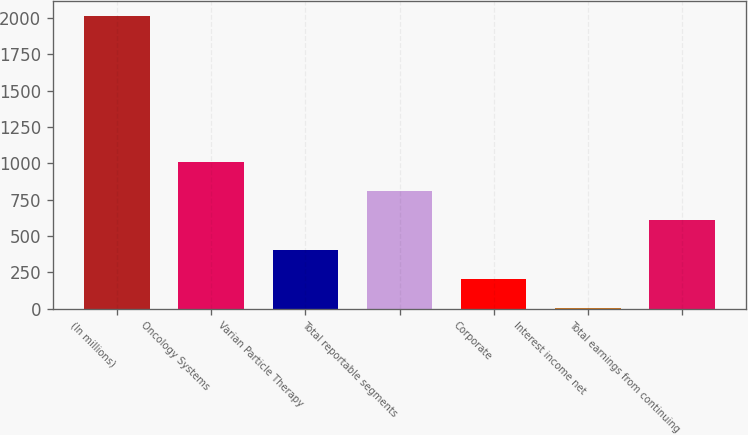<chart> <loc_0><loc_0><loc_500><loc_500><bar_chart><fcel>(In millions)<fcel>Oncology Systems<fcel>Varian Particle Therapy<fcel>Total reportable segments<fcel>Corporate<fcel>Interest income net<fcel>Total earnings from continuing<nl><fcel>2017<fcel>1009.95<fcel>405.72<fcel>808.54<fcel>204.31<fcel>2.9<fcel>607.13<nl></chart> 